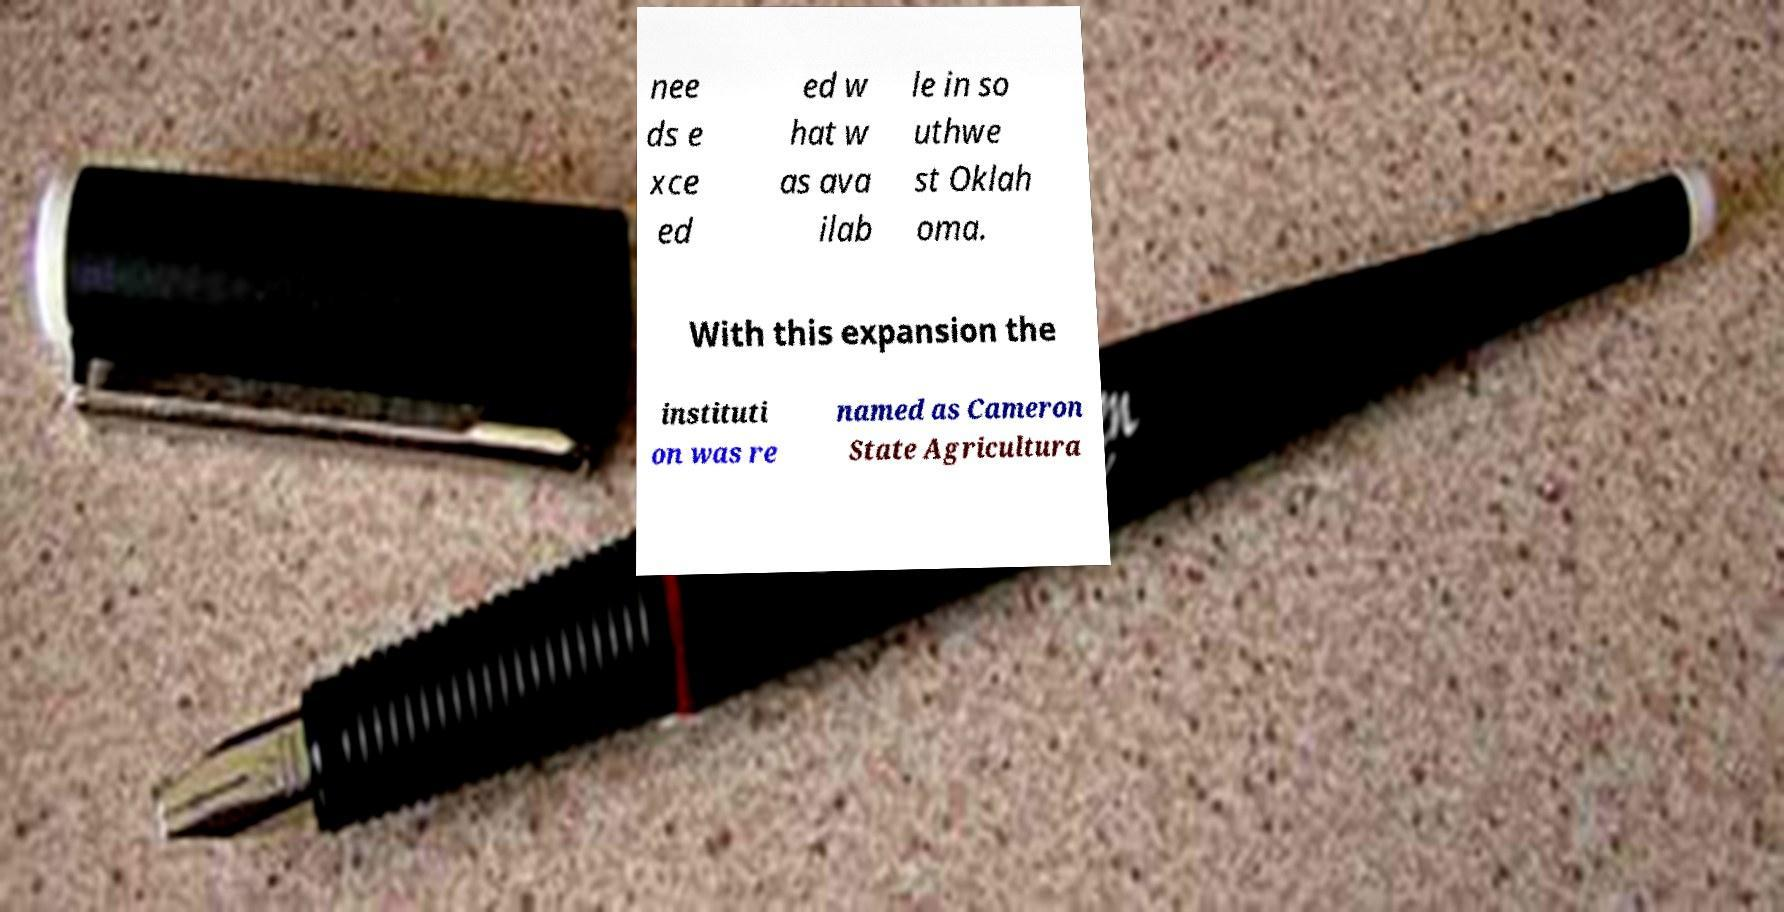Can you read and provide the text displayed in the image?This photo seems to have some interesting text. Can you extract and type it out for me? nee ds e xce ed ed w hat w as ava ilab le in so uthwe st Oklah oma. With this expansion the instituti on was re named as Cameron State Agricultura 